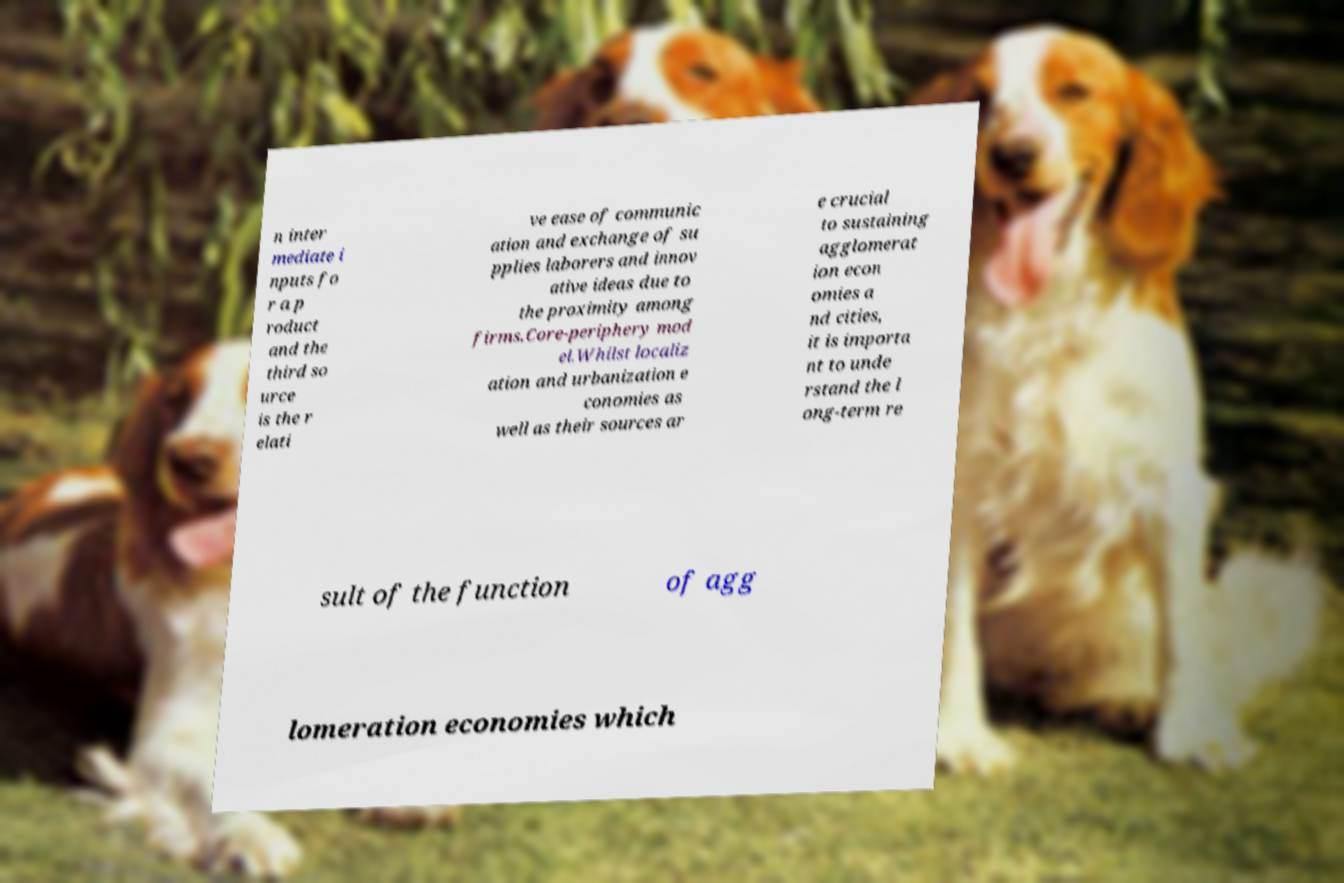I need the written content from this picture converted into text. Can you do that? n inter mediate i nputs fo r a p roduct and the third so urce is the r elati ve ease of communic ation and exchange of su pplies laborers and innov ative ideas due to the proximity among firms.Core-periphery mod el.Whilst localiz ation and urbanization e conomies as well as their sources ar e crucial to sustaining agglomerat ion econ omies a nd cities, it is importa nt to unde rstand the l ong-term re sult of the function of agg lomeration economies which 